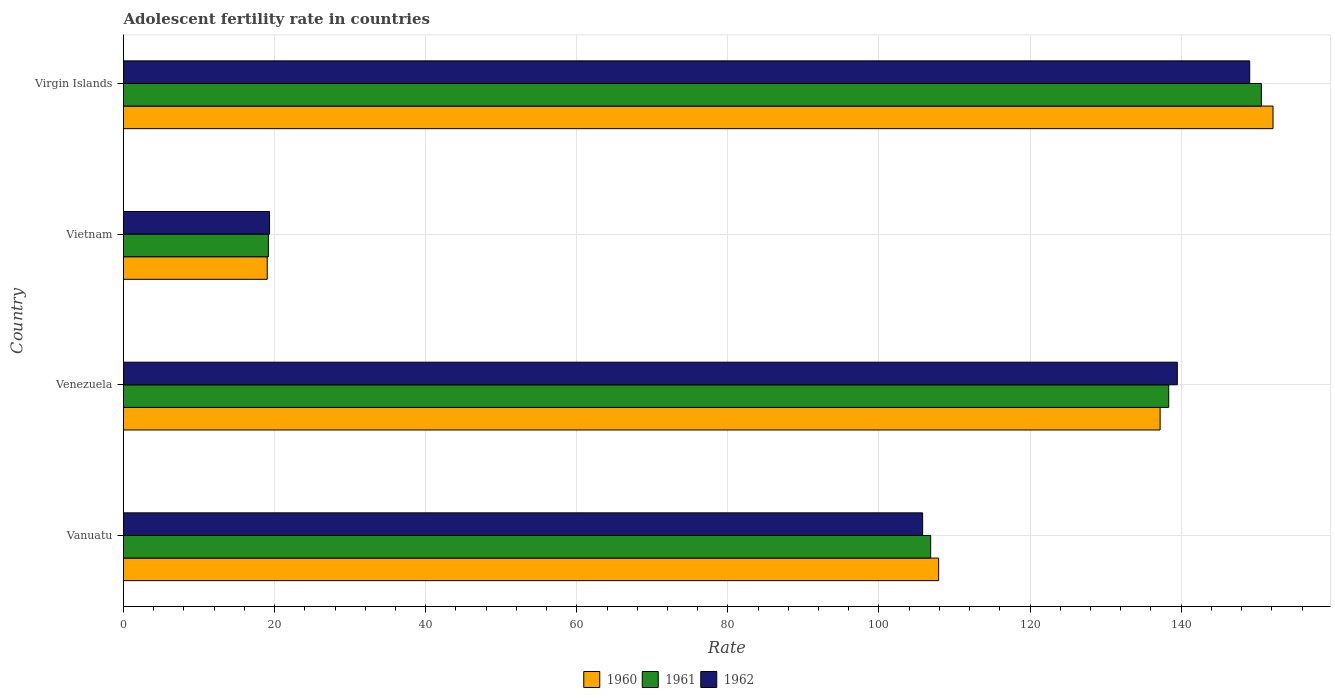How many different coloured bars are there?
Provide a succinct answer. 3. How many groups of bars are there?
Make the answer very short. 4. Are the number of bars per tick equal to the number of legend labels?
Keep it short and to the point. Yes. Are the number of bars on each tick of the Y-axis equal?
Provide a succinct answer. Yes. How many bars are there on the 1st tick from the top?
Keep it short and to the point. 3. What is the label of the 2nd group of bars from the top?
Offer a very short reply. Vietnam. In how many cases, is the number of bars for a given country not equal to the number of legend labels?
Your response must be concise. 0. What is the adolescent fertility rate in 1960 in Venezuela?
Your answer should be very brief. 137.21. Across all countries, what is the maximum adolescent fertility rate in 1961?
Make the answer very short. 150.61. Across all countries, what is the minimum adolescent fertility rate in 1962?
Your response must be concise. 19.33. In which country was the adolescent fertility rate in 1961 maximum?
Offer a terse response. Virgin Islands. In which country was the adolescent fertility rate in 1961 minimum?
Offer a very short reply. Vietnam. What is the total adolescent fertility rate in 1961 in the graph?
Make the answer very short. 414.98. What is the difference between the adolescent fertility rate in 1961 in Vanuatu and that in Virgin Islands?
Keep it short and to the point. -43.77. What is the difference between the adolescent fertility rate in 1960 in Virgin Islands and the adolescent fertility rate in 1961 in Venezuela?
Offer a very short reply. 13.81. What is the average adolescent fertility rate in 1960 per country?
Offer a terse response. 104.07. What is the difference between the adolescent fertility rate in 1960 and adolescent fertility rate in 1962 in Vanuatu?
Keep it short and to the point. 2.12. What is the ratio of the adolescent fertility rate in 1960 in Venezuela to that in Vietnam?
Keep it short and to the point. 7.21. Is the difference between the adolescent fertility rate in 1960 in Venezuela and Virgin Islands greater than the difference between the adolescent fertility rate in 1962 in Venezuela and Virgin Islands?
Offer a very short reply. No. What is the difference between the highest and the second highest adolescent fertility rate in 1960?
Your answer should be compact. 14.94. What is the difference between the highest and the lowest adolescent fertility rate in 1961?
Your answer should be compact. 131.44. In how many countries, is the adolescent fertility rate in 1960 greater than the average adolescent fertility rate in 1960 taken over all countries?
Give a very brief answer. 3. What does the 2nd bar from the bottom in Vanuatu represents?
Your answer should be very brief. 1961. Are the values on the major ticks of X-axis written in scientific E-notation?
Provide a succinct answer. No. Does the graph contain grids?
Ensure brevity in your answer.  Yes. How many legend labels are there?
Your answer should be compact. 3. How are the legend labels stacked?
Provide a succinct answer. Horizontal. What is the title of the graph?
Your answer should be compact. Adolescent fertility rate in countries. Does "2004" appear as one of the legend labels in the graph?
Offer a very short reply. No. What is the label or title of the X-axis?
Give a very brief answer. Rate. What is the label or title of the Y-axis?
Ensure brevity in your answer.  Country. What is the Rate in 1960 in Vanuatu?
Ensure brevity in your answer.  107.9. What is the Rate in 1961 in Vanuatu?
Offer a terse response. 106.84. What is the Rate in 1962 in Vanuatu?
Give a very brief answer. 105.78. What is the Rate in 1960 in Venezuela?
Your answer should be compact. 137.21. What is the Rate of 1961 in Venezuela?
Make the answer very short. 138.35. What is the Rate of 1962 in Venezuela?
Your response must be concise. 139.49. What is the Rate in 1960 in Vietnam?
Provide a succinct answer. 19.03. What is the Rate of 1961 in Vietnam?
Offer a terse response. 19.18. What is the Rate of 1962 in Vietnam?
Provide a succinct answer. 19.33. What is the Rate in 1960 in Virgin Islands?
Keep it short and to the point. 152.16. What is the Rate of 1961 in Virgin Islands?
Offer a terse response. 150.61. What is the Rate in 1962 in Virgin Islands?
Ensure brevity in your answer.  149.07. Across all countries, what is the maximum Rate in 1960?
Keep it short and to the point. 152.16. Across all countries, what is the maximum Rate in 1961?
Keep it short and to the point. 150.61. Across all countries, what is the maximum Rate in 1962?
Offer a terse response. 149.07. Across all countries, what is the minimum Rate of 1960?
Your answer should be compact. 19.03. Across all countries, what is the minimum Rate in 1961?
Provide a succinct answer. 19.18. Across all countries, what is the minimum Rate in 1962?
Give a very brief answer. 19.33. What is the total Rate in 1960 in the graph?
Provide a short and direct response. 416.29. What is the total Rate in 1961 in the graph?
Keep it short and to the point. 414.98. What is the total Rate of 1962 in the graph?
Ensure brevity in your answer.  413.68. What is the difference between the Rate of 1960 in Vanuatu and that in Venezuela?
Your answer should be compact. -29.32. What is the difference between the Rate of 1961 in Vanuatu and that in Venezuela?
Offer a terse response. -31.51. What is the difference between the Rate of 1962 in Vanuatu and that in Venezuela?
Provide a succinct answer. -33.71. What is the difference between the Rate of 1960 in Vanuatu and that in Vietnam?
Offer a terse response. 88.87. What is the difference between the Rate in 1961 in Vanuatu and that in Vietnam?
Ensure brevity in your answer.  87.66. What is the difference between the Rate of 1962 in Vanuatu and that in Vietnam?
Ensure brevity in your answer.  86.45. What is the difference between the Rate of 1960 in Vanuatu and that in Virgin Islands?
Your response must be concise. -44.26. What is the difference between the Rate in 1961 in Vanuatu and that in Virgin Islands?
Provide a succinct answer. -43.77. What is the difference between the Rate in 1962 in Vanuatu and that in Virgin Islands?
Your answer should be very brief. -43.29. What is the difference between the Rate of 1960 in Venezuela and that in Vietnam?
Your answer should be compact. 118.19. What is the difference between the Rate of 1961 in Venezuela and that in Vietnam?
Offer a very short reply. 119.17. What is the difference between the Rate of 1962 in Venezuela and that in Vietnam?
Offer a very short reply. 120.16. What is the difference between the Rate of 1960 in Venezuela and that in Virgin Islands?
Your response must be concise. -14.95. What is the difference between the Rate of 1961 in Venezuela and that in Virgin Islands?
Give a very brief answer. -12.26. What is the difference between the Rate of 1962 in Venezuela and that in Virgin Islands?
Your response must be concise. -9.58. What is the difference between the Rate of 1960 in Vietnam and that in Virgin Islands?
Your answer should be compact. -133.13. What is the difference between the Rate of 1961 in Vietnam and that in Virgin Islands?
Your answer should be very brief. -131.44. What is the difference between the Rate of 1962 in Vietnam and that in Virgin Islands?
Offer a terse response. -129.74. What is the difference between the Rate of 1960 in Vanuatu and the Rate of 1961 in Venezuela?
Ensure brevity in your answer.  -30.45. What is the difference between the Rate in 1960 in Vanuatu and the Rate in 1962 in Venezuela?
Give a very brief answer. -31.59. What is the difference between the Rate of 1961 in Vanuatu and the Rate of 1962 in Venezuela?
Offer a very short reply. -32.65. What is the difference between the Rate of 1960 in Vanuatu and the Rate of 1961 in Vietnam?
Provide a succinct answer. 88.72. What is the difference between the Rate of 1960 in Vanuatu and the Rate of 1962 in Vietnam?
Give a very brief answer. 88.57. What is the difference between the Rate in 1961 in Vanuatu and the Rate in 1962 in Vietnam?
Offer a terse response. 87.51. What is the difference between the Rate in 1960 in Vanuatu and the Rate in 1961 in Virgin Islands?
Offer a terse response. -42.72. What is the difference between the Rate in 1960 in Vanuatu and the Rate in 1962 in Virgin Islands?
Offer a terse response. -41.17. What is the difference between the Rate in 1961 in Vanuatu and the Rate in 1962 in Virgin Islands?
Provide a succinct answer. -42.23. What is the difference between the Rate of 1960 in Venezuela and the Rate of 1961 in Vietnam?
Your answer should be compact. 118.03. What is the difference between the Rate in 1960 in Venezuela and the Rate in 1962 in Vietnam?
Provide a short and direct response. 117.88. What is the difference between the Rate of 1961 in Venezuela and the Rate of 1962 in Vietnam?
Give a very brief answer. 119.02. What is the difference between the Rate in 1960 in Venezuela and the Rate in 1961 in Virgin Islands?
Provide a succinct answer. -13.4. What is the difference between the Rate in 1960 in Venezuela and the Rate in 1962 in Virgin Islands?
Give a very brief answer. -11.86. What is the difference between the Rate of 1961 in Venezuela and the Rate of 1962 in Virgin Islands?
Keep it short and to the point. -10.72. What is the difference between the Rate of 1960 in Vietnam and the Rate of 1961 in Virgin Islands?
Offer a terse response. -131.59. What is the difference between the Rate of 1960 in Vietnam and the Rate of 1962 in Virgin Islands?
Make the answer very short. -130.04. What is the difference between the Rate in 1961 in Vietnam and the Rate in 1962 in Virgin Islands?
Provide a short and direct response. -129.89. What is the average Rate in 1960 per country?
Give a very brief answer. 104.07. What is the average Rate in 1961 per country?
Give a very brief answer. 103.75. What is the average Rate of 1962 per country?
Provide a succinct answer. 103.42. What is the difference between the Rate in 1960 and Rate in 1961 in Vanuatu?
Your answer should be compact. 1.06. What is the difference between the Rate of 1960 and Rate of 1962 in Vanuatu?
Offer a very short reply. 2.12. What is the difference between the Rate in 1961 and Rate in 1962 in Vanuatu?
Offer a terse response. 1.06. What is the difference between the Rate of 1960 and Rate of 1961 in Venezuela?
Keep it short and to the point. -1.14. What is the difference between the Rate in 1960 and Rate in 1962 in Venezuela?
Give a very brief answer. -2.28. What is the difference between the Rate of 1961 and Rate of 1962 in Venezuela?
Your answer should be very brief. -1.14. What is the difference between the Rate in 1960 and Rate in 1961 in Vietnam?
Make the answer very short. -0.15. What is the difference between the Rate in 1960 and Rate in 1962 in Vietnam?
Make the answer very short. -0.31. What is the difference between the Rate in 1961 and Rate in 1962 in Vietnam?
Make the answer very short. -0.15. What is the difference between the Rate in 1960 and Rate in 1961 in Virgin Islands?
Provide a short and direct response. 1.54. What is the difference between the Rate of 1960 and Rate of 1962 in Virgin Islands?
Your answer should be compact. 3.09. What is the difference between the Rate of 1961 and Rate of 1962 in Virgin Islands?
Your answer should be very brief. 1.54. What is the ratio of the Rate in 1960 in Vanuatu to that in Venezuela?
Make the answer very short. 0.79. What is the ratio of the Rate in 1961 in Vanuatu to that in Venezuela?
Provide a short and direct response. 0.77. What is the ratio of the Rate of 1962 in Vanuatu to that in Venezuela?
Your answer should be very brief. 0.76. What is the ratio of the Rate in 1960 in Vanuatu to that in Vietnam?
Your answer should be compact. 5.67. What is the ratio of the Rate of 1961 in Vanuatu to that in Vietnam?
Your response must be concise. 5.57. What is the ratio of the Rate in 1962 in Vanuatu to that in Vietnam?
Provide a short and direct response. 5.47. What is the ratio of the Rate in 1960 in Vanuatu to that in Virgin Islands?
Provide a succinct answer. 0.71. What is the ratio of the Rate in 1961 in Vanuatu to that in Virgin Islands?
Your answer should be compact. 0.71. What is the ratio of the Rate of 1962 in Vanuatu to that in Virgin Islands?
Ensure brevity in your answer.  0.71. What is the ratio of the Rate of 1960 in Venezuela to that in Vietnam?
Give a very brief answer. 7.21. What is the ratio of the Rate of 1961 in Venezuela to that in Vietnam?
Provide a short and direct response. 7.21. What is the ratio of the Rate in 1962 in Venezuela to that in Vietnam?
Provide a succinct answer. 7.22. What is the ratio of the Rate in 1960 in Venezuela to that in Virgin Islands?
Your response must be concise. 0.9. What is the ratio of the Rate in 1961 in Venezuela to that in Virgin Islands?
Your response must be concise. 0.92. What is the ratio of the Rate in 1962 in Venezuela to that in Virgin Islands?
Ensure brevity in your answer.  0.94. What is the ratio of the Rate in 1960 in Vietnam to that in Virgin Islands?
Offer a terse response. 0.12. What is the ratio of the Rate in 1961 in Vietnam to that in Virgin Islands?
Your response must be concise. 0.13. What is the ratio of the Rate of 1962 in Vietnam to that in Virgin Islands?
Keep it short and to the point. 0.13. What is the difference between the highest and the second highest Rate of 1960?
Offer a very short reply. 14.95. What is the difference between the highest and the second highest Rate in 1961?
Provide a short and direct response. 12.26. What is the difference between the highest and the second highest Rate in 1962?
Make the answer very short. 9.58. What is the difference between the highest and the lowest Rate in 1960?
Your response must be concise. 133.13. What is the difference between the highest and the lowest Rate of 1961?
Keep it short and to the point. 131.44. What is the difference between the highest and the lowest Rate of 1962?
Provide a succinct answer. 129.74. 